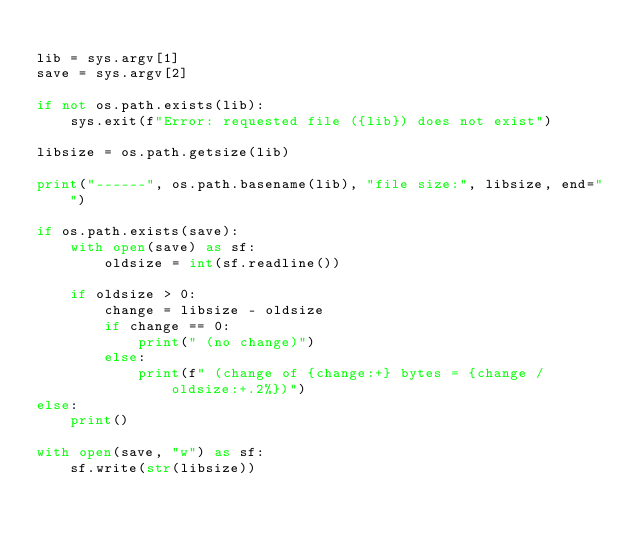<code> <loc_0><loc_0><loc_500><loc_500><_Python_>
lib = sys.argv[1]
save = sys.argv[2]

if not os.path.exists(lib):
    sys.exit(f"Error: requested file ({lib}) does not exist")

libsize = os.path.getsize(lib)

print("------", os.path.basename(lib), "file size:", libsize, end="")

if os.path.exists(save):
    with open(save) as sf:
        oldsize = int(sf.readline())

    if oldsize > 0:
        change = libsize - oldsize
        if change == 0:
            print(" (no change)")
        else:
            print(f" (change of {change:+} bytes = {change / oldsize:+.2%})")
else:
    print()

with open(save, "w") as sf:
    sf.write(str(libsize))
</code> 